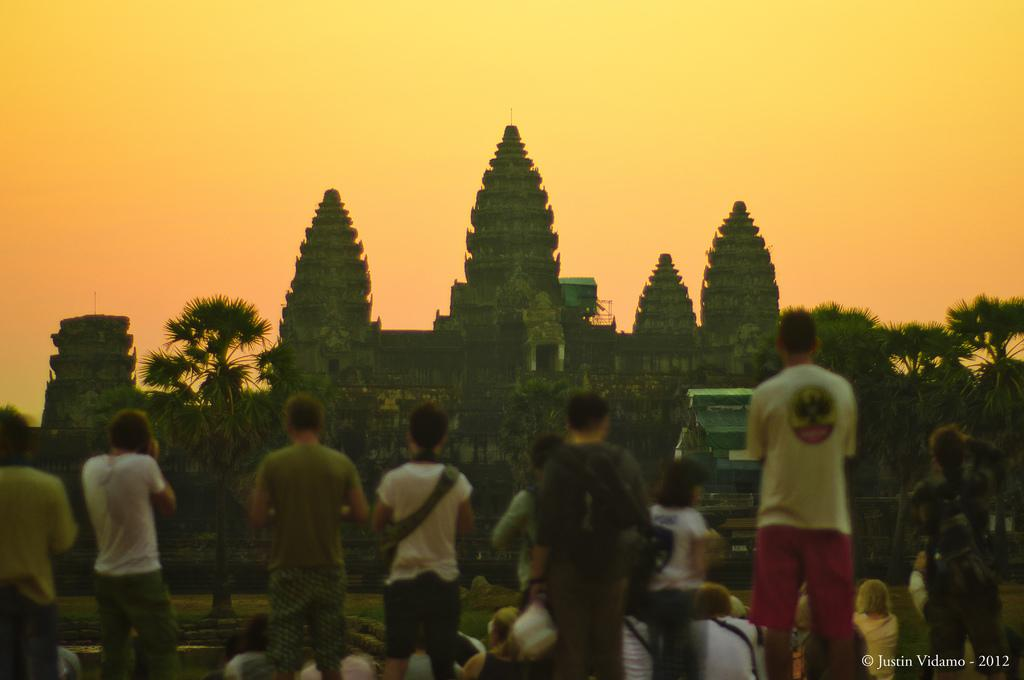What can be found in the bottom left corner of the image? There is a watermark in the bottom left corner of the image. What is visible in the background of the image? There are persons, trees, buildings, grass, and clouds in the background of the image. What type of apparel is the locket stored in within the crate in the image? There is no apparel, locket, or crate present in the image. 